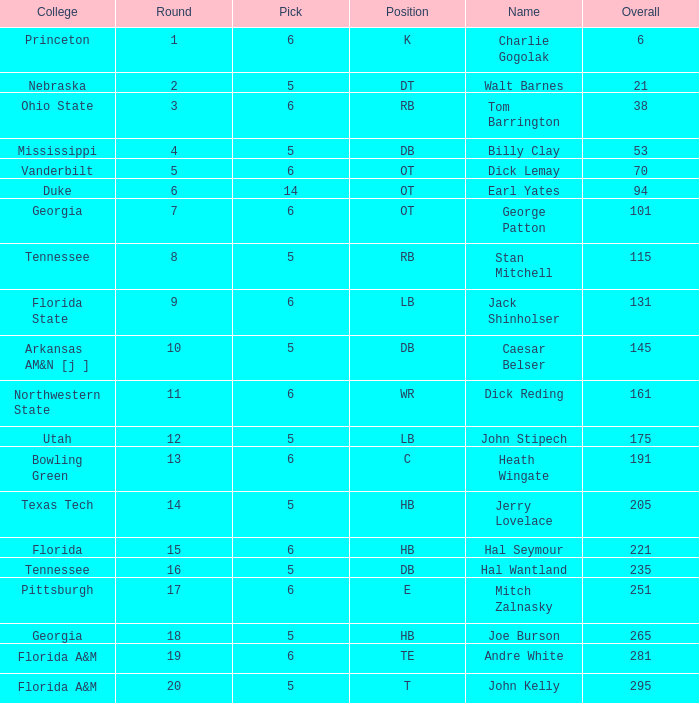What is the top pick, when round is over 15, and when college is "tennessee"? 5.0. 